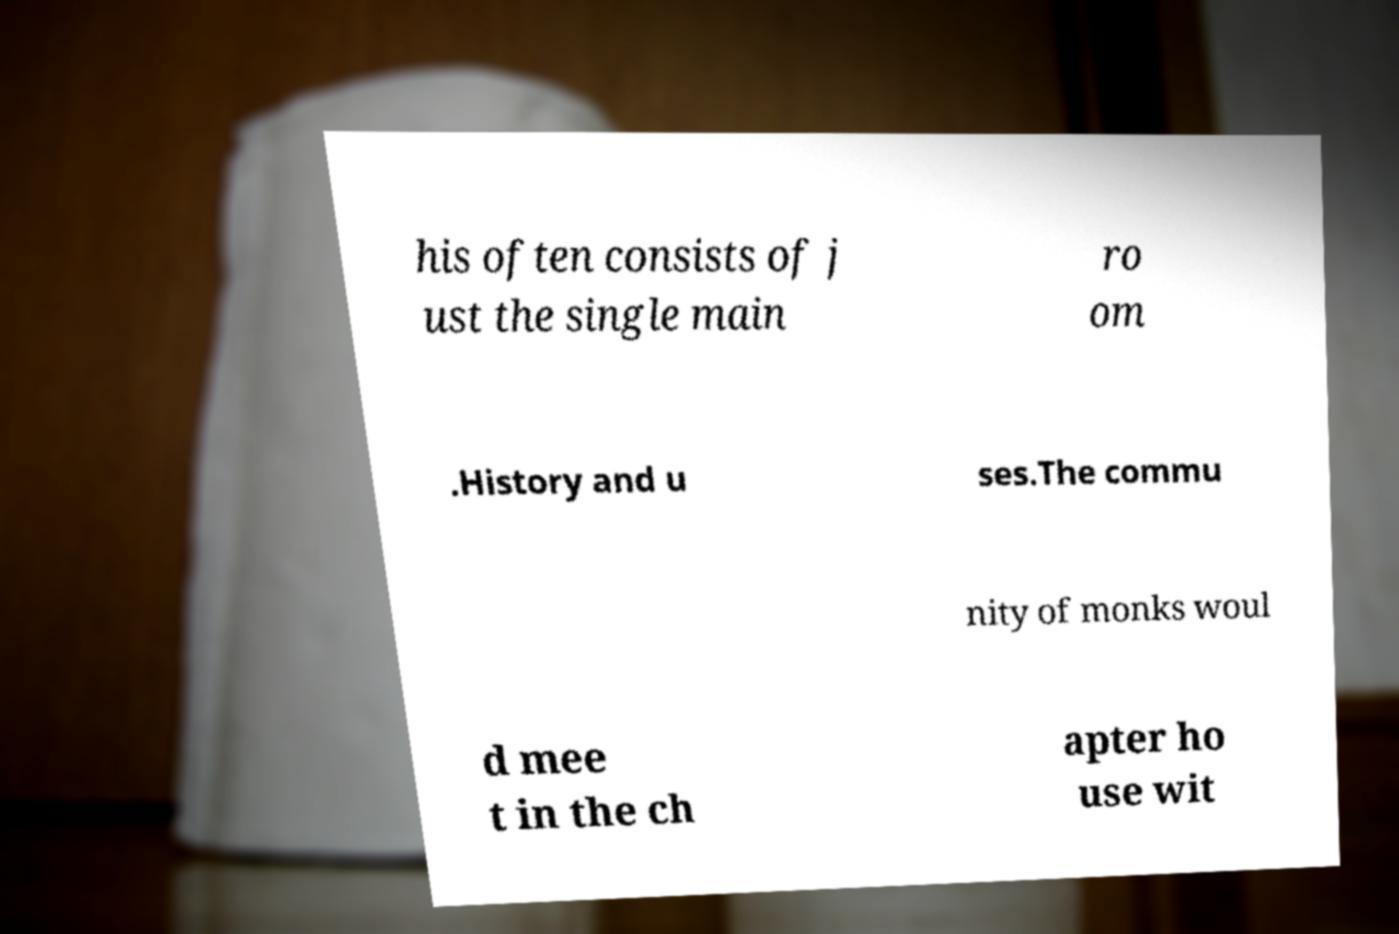Please identify and transcribe the text found in this image. his often consists of j ust the single main ro om .History and u ses.The commu nity of monks woul d mee t in the ch apter ho use wit 